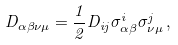Convert formula to latex. <formula><loc_0><loc_0><loc_500><loc_500>D _ { \alpha \beta \nu \mu } = \frac { 1 } { 2 } D _ { i j } \sigma ^ { i } _ { \alpha \beta } \sigma ^ { j } _ { \nu \mu } \, ,</formula> 